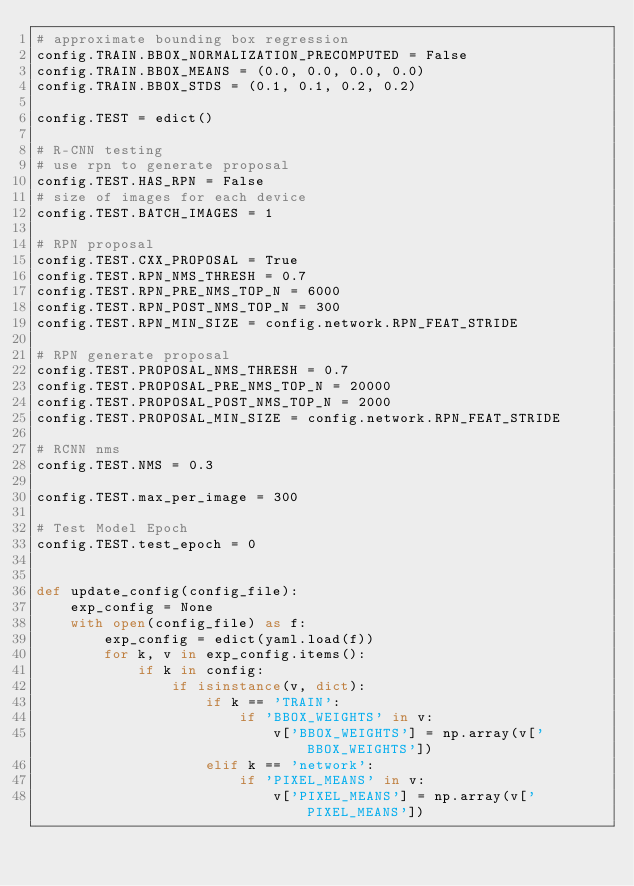Convert code to text. <code><loc_0><loc_0><loc_500><loc_500><_Python_># approximate bounding box regression
config.TRAIN.BBOX_NORMALIZATION_PRECOMPUTED = False
config.TRAIN.BBOX_MEANS = (0.0, 0.0, 0.0, 0.0)
config.TRAIN.BBOX_STDS = (0.1, 0.1, 0.2, 0.2)

config.TEST = edict()

# R-CNN testing
# use rpn to generate proposal
config.TEST.HAS_RPN = False
# size of images for each device
config.TEST.BATCH_IMAGES = 1

# RPN proposal
config.TEST.CXX_PROPOSAL = True
config.TEST.RPN_NMS_THRESH = 0.7
config.TEST.RPN_PRE_NMS_TOP_N = 6000
config.TEST.RPN_POST_NMS_TOP_N = 300
config.TEST.RPN_MIN_SIZE = config.network.RPN_FEAT_STRIDE

# RPN generate proposal
config.TEST.PROPOSAL_NMS_THRESH = 0.7
config.TEST.PROPOSAL_PRE_NMS_TOP_N = 20000
config.TEST.PROPOSAL_POST_NMS_TOP_N = 2000
config.TEST.PROPOSAL_MIN_SIZE = config.network.RPN_FEAT_STRIDE

# RCNN nms
config.TEST.NMS = 0.3

config.TEST.max_per_image = 300

# Test Model Epoch
config.TEST.test_epoch = 0


def update_config(config_file):
    exp_config = None
    with open(config_file) as f:
        exp_config = edict(yaml.load(f))
        for k, v in exp_config.items():
            if k in config:
                if isinstance(v, dict):
                    if k == 'TRAIN':
                        if 'BBOX_WEIGHTS' in v:
                            v['BBOX_WEIGHTS'] = np.array(v['BBOX_WEIGHTS'])
                    elif k == 'network':
                        if 'PIXEL_MEANS' in v:
                            v['PIXEL_MEANS'] = np.array(v['PIXEL_MEANS'])</code> 